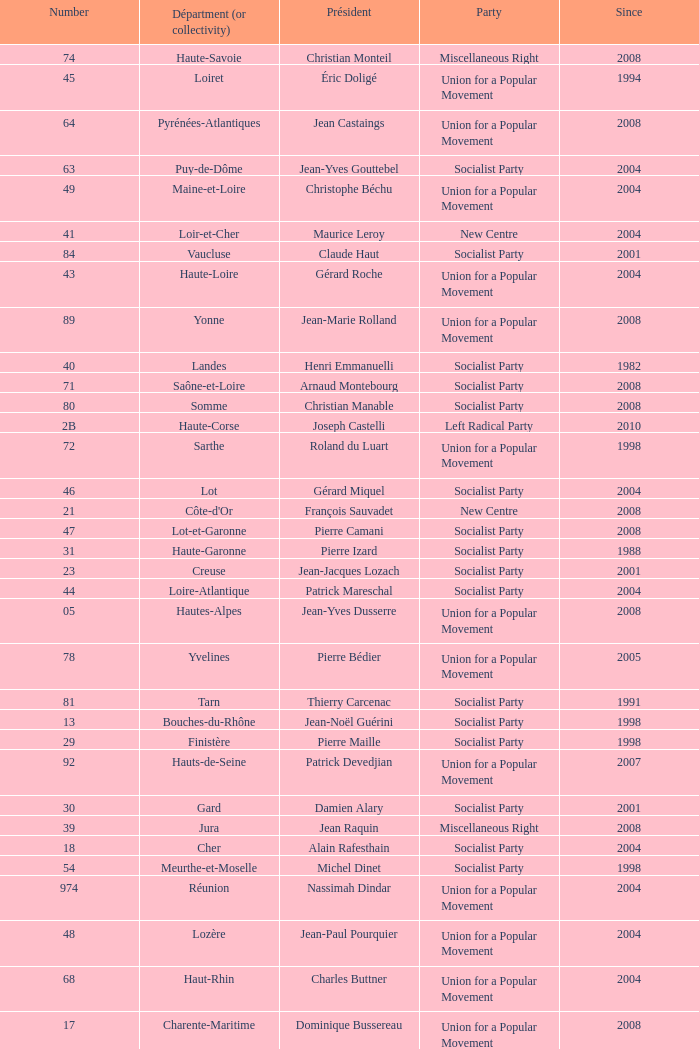Which department has Guy-Dominique Kennel as president since 2008? Bas-Rhin. 